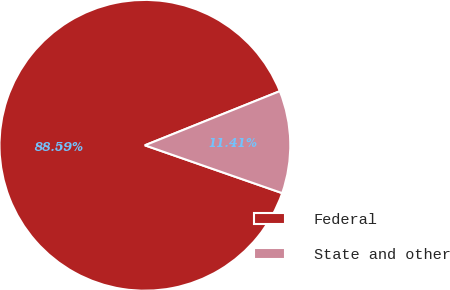Convert chart. <chart><loc_0><loc_0><loc_500><loc_500><pie_chart><fcel>Federal<fcel>State and other<nl><fcel>88.59%<fcel>11.41%<nl></chart> 